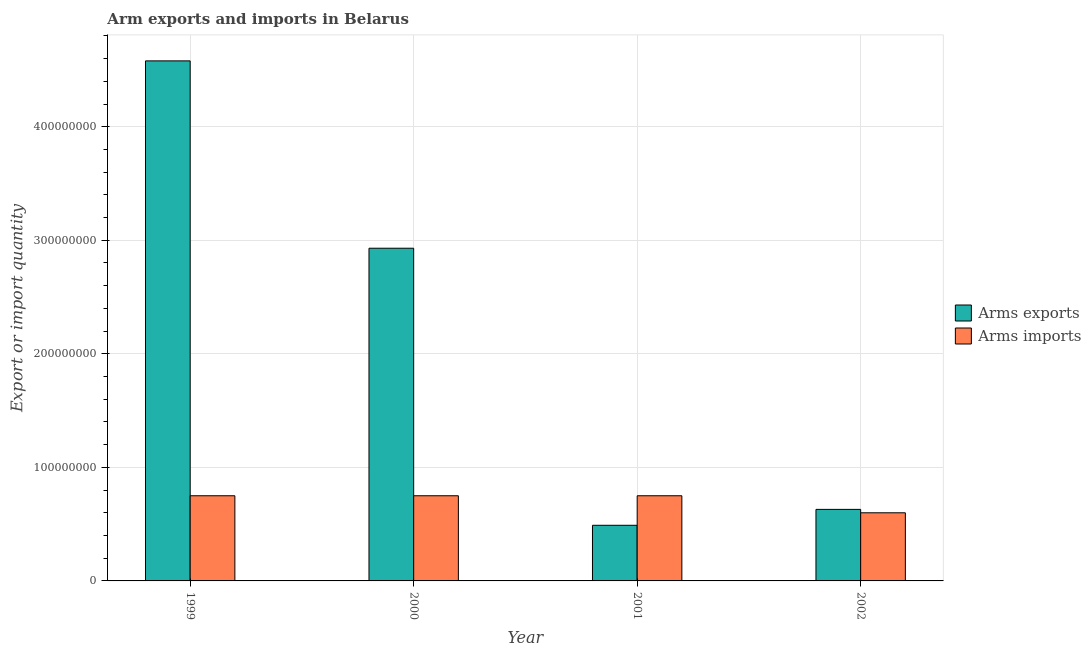How many different coloured bars are there?
Your answer should be very brief. 2. Are the number of bars on each tick of the X-axis equal?
Your answer should be compact. Yes. In how many cases, is the number of bars for a given year not equal to the number of legend labels?
Your answer should be compact. 0. What is the arms imports in 2001?
Provide a short and direct response. 7.50e+07. Across all years, what is the maximum arms exports?
Your response must be concise. 4.58e+08. Across all years, what is the minimum arms exports?
Keep it short and to the point. 4.90e+07. In which year was the arms imports maximum?
Make the answer very short. 1999. What is the total arms exports in the graph?
Your response must be concise. 8.63e+08. What is the difference between the arms exports in 2000 and that in 2001?
Your answer should be very brief. 2.44e+08. What is the difference between the arms exports in 2001 and the arms imports in 1999?
Provide a succinct answer. -4.09e+08. What is the average arms imports per year?
Offer a terse response. 7.12e+07. In the year 2000, what is the difference between the arms exports and arms imports?
Give a very brief answer. 0. In how many years, is the arms imports greater than 240000000?
Your answer should be compact. 0. What is the ratio of the arms imports in 2000 to that in 2002?
Offer a terse response. 1.25. Is the arms exports in 2001 less than that in 2002?
Offer a very short reply. Yes. What is the difference between the highest and the lowest arms imports?
Offer a terse response. 1.50e+07. What does the 1st bar from the left in 2002 represents?
Ensure brevity in your answer.  Arms exports. What does the 2nd bar from the right in 2002 represents?
Offer a terse response. Arms exports. How many bars are there?
Offer a very short reply. 8. How many years are there in the graph?
Your answer should be very brief. 4. Are the values on the major ticks of Y-axis written in scientific E-notation?
Keep it short and to the point. No. Does the graph contain any zero values?
Keep it short and to the point. No. Does the graph contain grids?
Make the answer very short. Yes. How many legend labels are there?
Provide a succinct answer. 2. What is the title of the graph?
Offer a very short reply. Arm exports and imports in Belarus. Does "RDB concessional" appear as one of the legend labels in the graph?
Provide a succinct answer. No. What is the label or title of the X-axis?
Give a very brief answer. Year. What is the label or title of the Y-axis?
Provide a succinct answer. Export or import quantity. What is the Export or import quantity in Arms exports in 1999?
Offer a very short reply. 4.58e+08. What is the Export or import quantity in Arms imports in 1999?
Keep it short and to the point. 7.50e+07. What is the Export or import quantity of Arms exports in 2000?
Keep it short and to the point. 2.93e+08. What is the Export or import quantity in Arms imports in 2000?
Keep it short and to the point. 7.50e+07. What is the Export or import quantity of Arms exports in 2001?
Provide a short and direct response. 4.90e+07. What is the Export or import quantity of Arms imports in 2001?
Keep it short and to the point. 7.50e+07. What is the Export or import quantity in Arms exports in 2002?
Offer a terse response. 6.30e+07. What is the Export or import quantity in Arms imports in 2002?
Offer a terse response. 6.00e+07. Across all years, what is the maximum Export or import quantity of Arms exports?
Your response must be concise. 4.58e+08. Across all years, what is the maximum Export or import quantity of Arms imports?
Keep it short and to the point. 7.50e+07. Across all years, what is the minimum Export or import quantity in Arms exports?
Provide a short and direct response. 4.90e+07. Across all years, what is the minimum Export or import quantity in Arms imports?
Make the answer very short. 6.00e+07. What is the total Export or import quantity of Arms exports in the graph?
Ensure brevity in your answer.  8.63e+08. What is the total Export or import quantity of Arms imports in the graph?
Provide a short and direct response. 2.85e+08. What is the difference between the Export or import quantity of Arms exports in 1999 and that in 2000?
Your answer should be very brief. 1.65e+08. What is the difference between the Export or import quantity in Arms exports in 1999 and that in 2001?
Give a very brief answer. 4.09e+08. What is the difference between the Export or import quantity in Arms exports in 1999 and that in 2002?
Provide a succinct answer. 3.95e+08. What is the difference between the Export or import quantity of Arms imports in 1999 and that in 2002?
Make the answer very short. 1.50e+07. What is the difference between the Export or import quantity in Arms exports in 2000 and that in 2001?
Provide a succinct answer. 2.44e+08. What is the difference between the Export or import quantity of Arms imports in 2000 and that in 2001?
Your response must be concise. 0. What is the difference between the Export or import quantity in Arms exports in 2000 and that in 2002?
Make the answer very short. 2.30e+08. What is the difference between the Export or import quantity in Arms imports in 2000 and that in 2002?
Offer a terse response. 1.50e+07. What is the difference between the Export or import quantity of Arms exports in 2001 and that in 2002?
Ensure brevity in your answer.  -1.40e+07. What is the difference between the Export or import quantity of Arms imports in 2001 and that in 2002?
Give a very brief answer. 1.50e+07. What is the difference between the Export or import quantity in Arms exports in 1999 and the Export or import quantity in Arms imports in 2000?
Provide a succinct answer. 3.83e+08. What is the difference between the Export or import quantity of Arms exports in 1999 and the Export or import quantity of Arms imports in 2001?
Give a very brief answer. 3.83e+08. What is the difference between the Export or import quantity of Arms exports in 1999 and the Export or import quantity of Arms imports in 2002?
Your answer should be very brief. 3.98e+08. What is the difference between the Export or import quantity of Arms exports in 2000 and the Export or import quantity of Arms imports in 2001?
Provide a short and direct response. 2.18e+08. What is the difference between the Export or import quantity in Arms exports in 2000 and the Export or import quantity in Arms imports in 2002?
Your answer should be very brief. 2.33e+08. What is the difference between the Export or import quantity in Arms exports in 2001 and the Export or import quantity in Arms imports in 2002?
Offer a very short reply. -1.10e+07. What is the average Export or import quantity in Arms exports per year?
Provide a succinct answer. 2.16e+08. What is the average Export or import quantity of Arms imports per year?
Make the answer very short. 7.12e+07. In the year 1999, what is the difference between the Export or import quantity of Arms exports and Export or import quantity of Arms imports?
Offer a very short reply. 3.83e+08. In the year 2000, what is the difference between the Export or import quantity of Arms exports and Export or import quantity of Arms imports?
Offer a very short reply. 2.18e+08. In the year 2001, what is the difference between the Export or import quantity of Arms exports and Export or import quantity of Arms imports?
Provide a short and direct response. -2.60e+07. In the year 2002, what is the difference between the Export or import quantity of Arms exports and Export or import quantity of Arms imports?
Your answer should be very brief. 3.00e+06. What is the ratio of the Export or import quantity in Arms exports in 1999 to that in 2000?
Offer a very short reply. 1.56. What is the ratio of the Export or import quantity in Arms imports in 1999 to that in 2000?
Your answer should be compact. 1. What is the ratio of the Export or import quantity of Arms exports in 1999 to that in 2001?
Provide a short and direct response. 9.35. What is the ratio of the Export or import quantity in Arms imports in 1999 to that in 2001?
Provide a succinct answer. 1. What is the ratio of the Export or import quantity of Arms exports in 1999 to that in 2002?
Your response must be concise. 7.27. What is the ratio of the Export or import quantity in Arms exports in 2000 to that in 2001?
Your response must be concise. 5.98. What is the ratio of the Export or import quantity of Arms exports in 2000 to that in 2002?
Your answer should be compact. 4.65. What is the ratio of the Export or import quantity of Arms imports in 2000 to that in 2002?
Keep it short and to the point. 1.25. What is the difference between the highest and the second highest Export or import quantity of Arms exports?
Provide a short and direct response. 1.65e+08. What is the difference between the highest and the lowest Export or import quantity in Arms exports?
Your answer should be compact. 4.09e+08. What is the difference between the highest and the lowest Export or import quantity of Arms imports?
Offer a very short reply. 1.50e+07. 